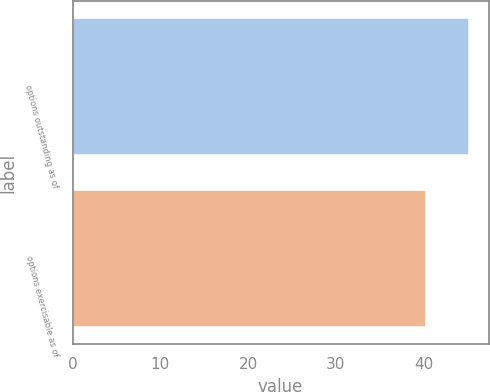Convert chart to OTSL. <chart><loc_0><loc_0><loc_500><loc_500><bar_chart><fcel>options outstanding as of<fcel>options exercisable as of<nl><fcel>45.18<fcel>40.28<nl></chart> 